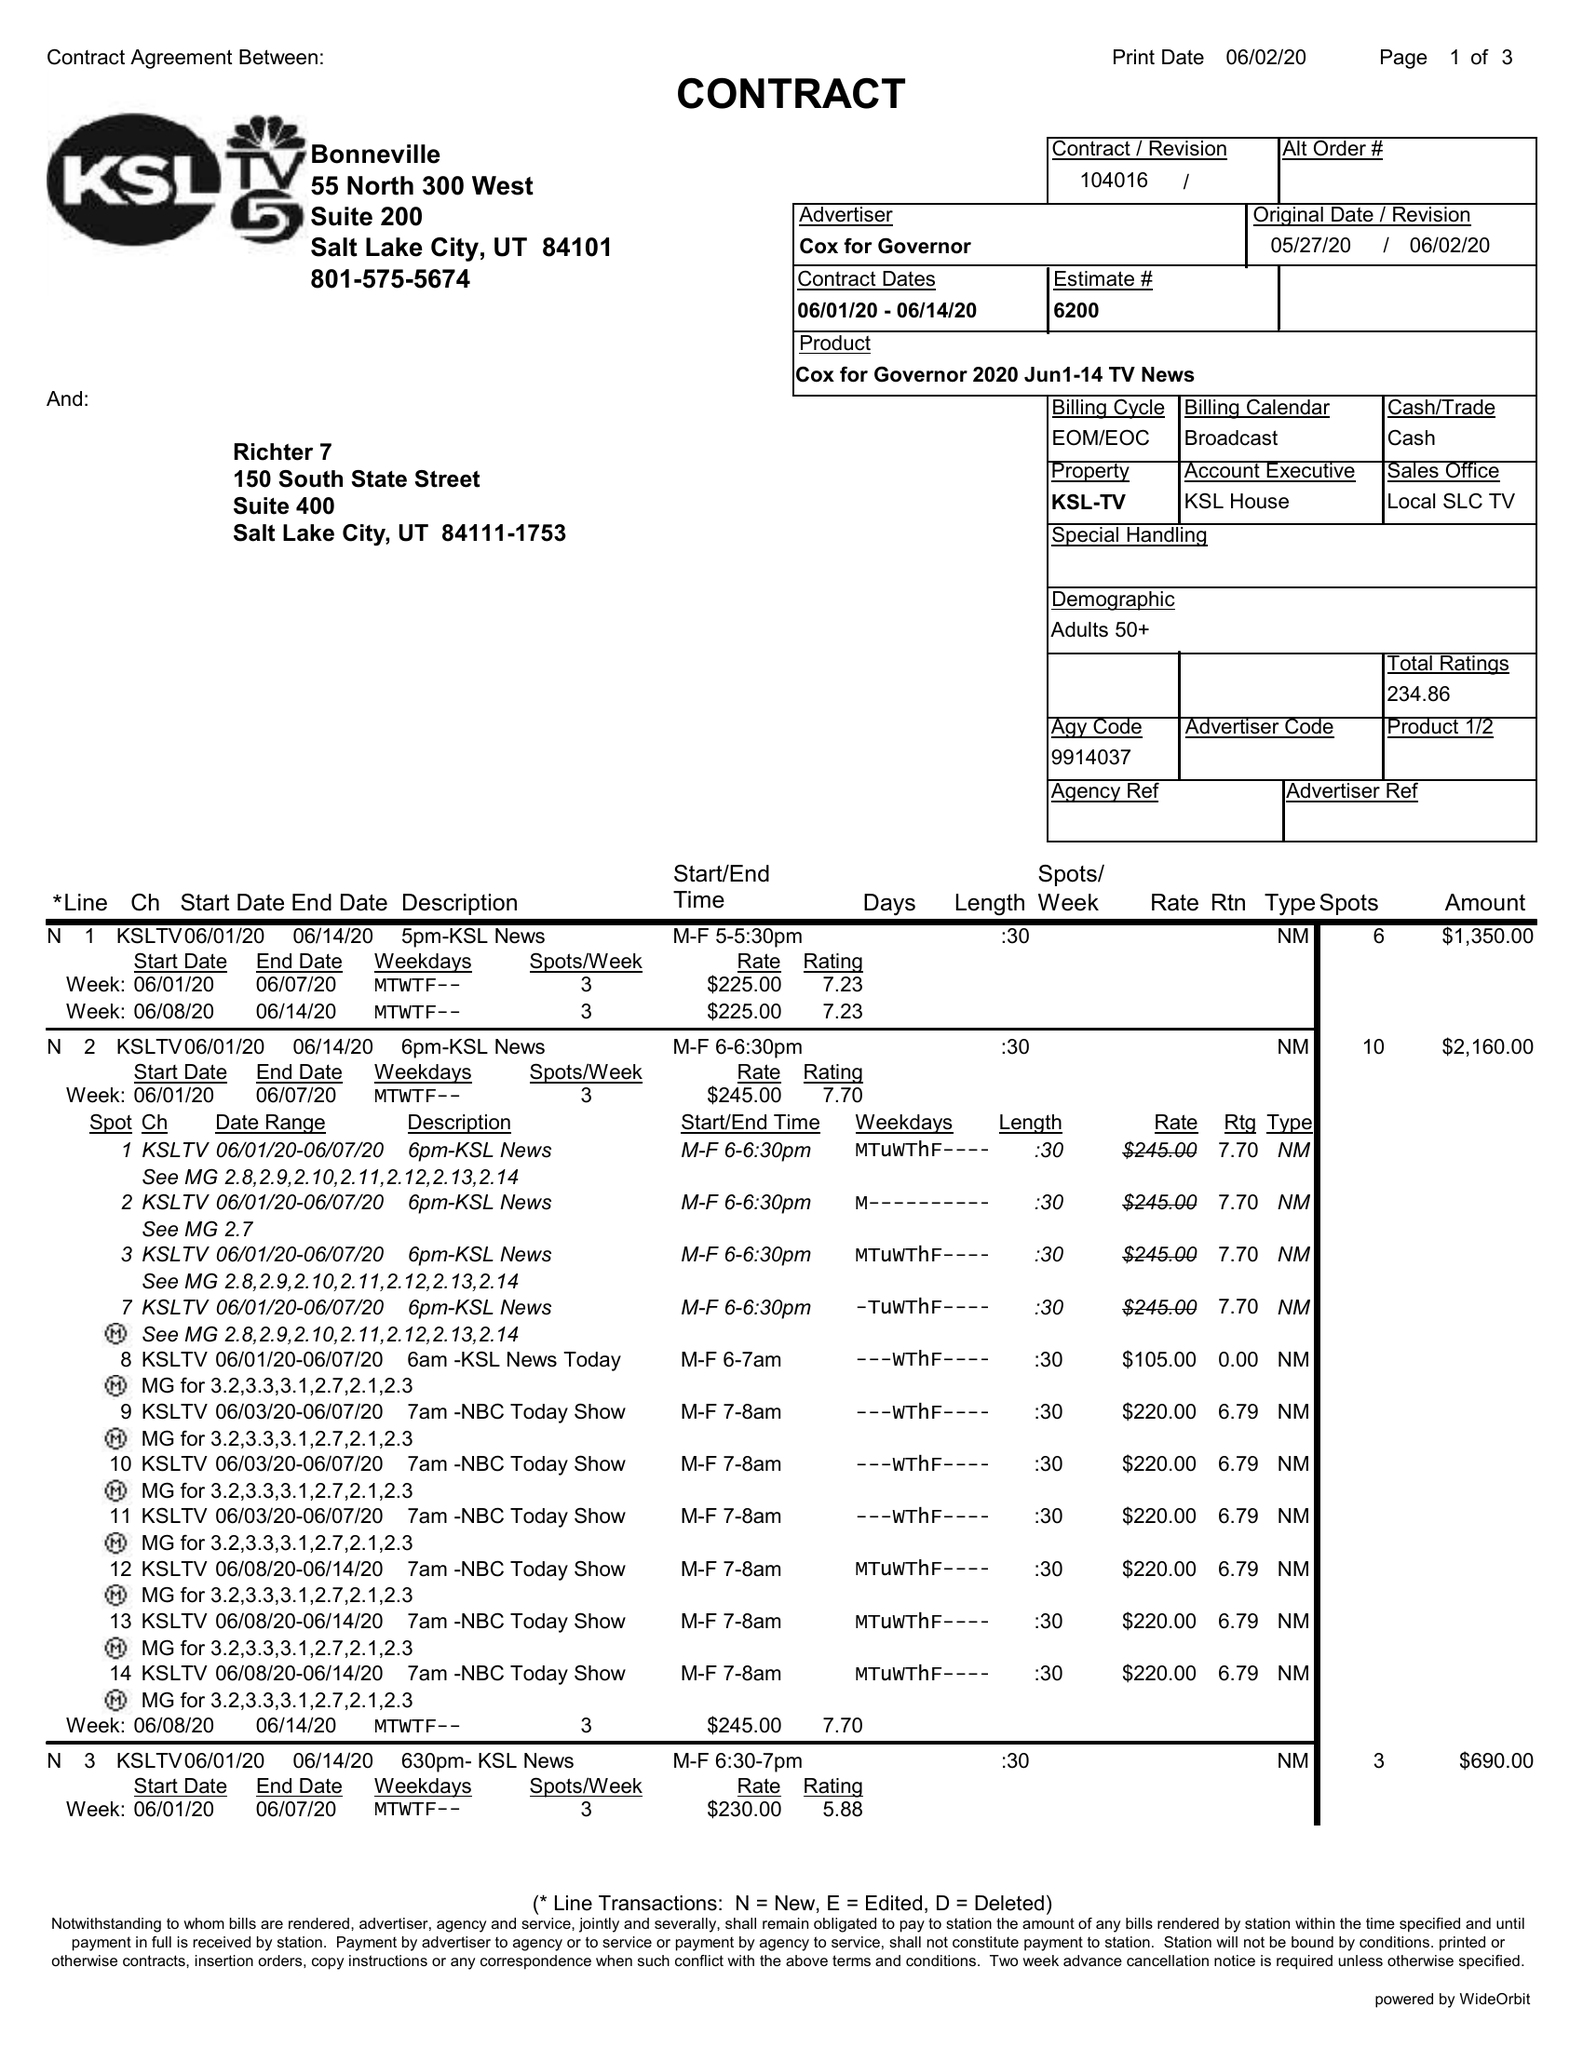What is the value for the contract_num?
Answer the question using a single word or phrase. 104016 